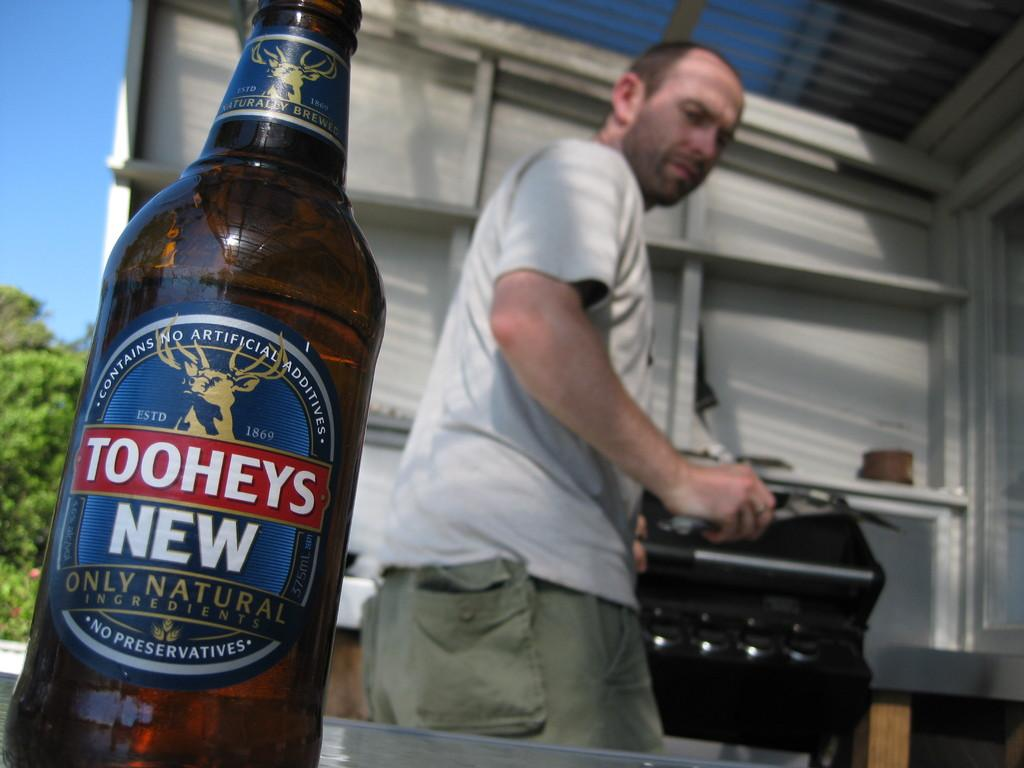Provide a one-sentence caption for the provided image. Man cooking behind a Toohey's only natural beer bottle. 